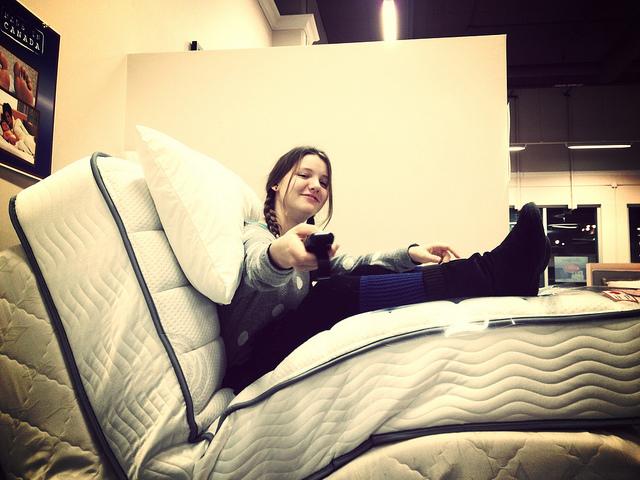What is she holding?
Give a very brief answer. Remote. Is this her home?
Keep it brief. No. What kind of bed is this?
Write a very short answer. Adjustable. 